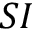<formula> <loc_0><loc_0><loc_500><loc_500>S I</formula> 